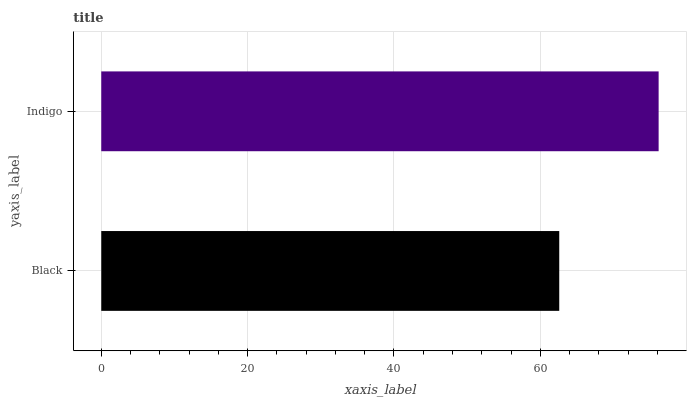Is Black the minimum?
Answer yes or no. Yes. Is Indigo the maximum?
Answer yes or no. Yes. Is Indigo the minimum?
Answer yes or no. No. Is Indigo greater than Black?
Answer yes or no. Yes. Is Black less than Indigo?
Answer yes or no. Yes. Is Black greater than Indigo?
Answer yes or no. No. Is Indigo less than Black?
Answer yes or no. No. Is Indigo the high median?
Answer yes or no. Yes. Is Black the low median?
Answer yes or no. Yes. Is Black the high median?
Answer yes or no. No. Is Indigo the low median?
Answer yes or no. No. 